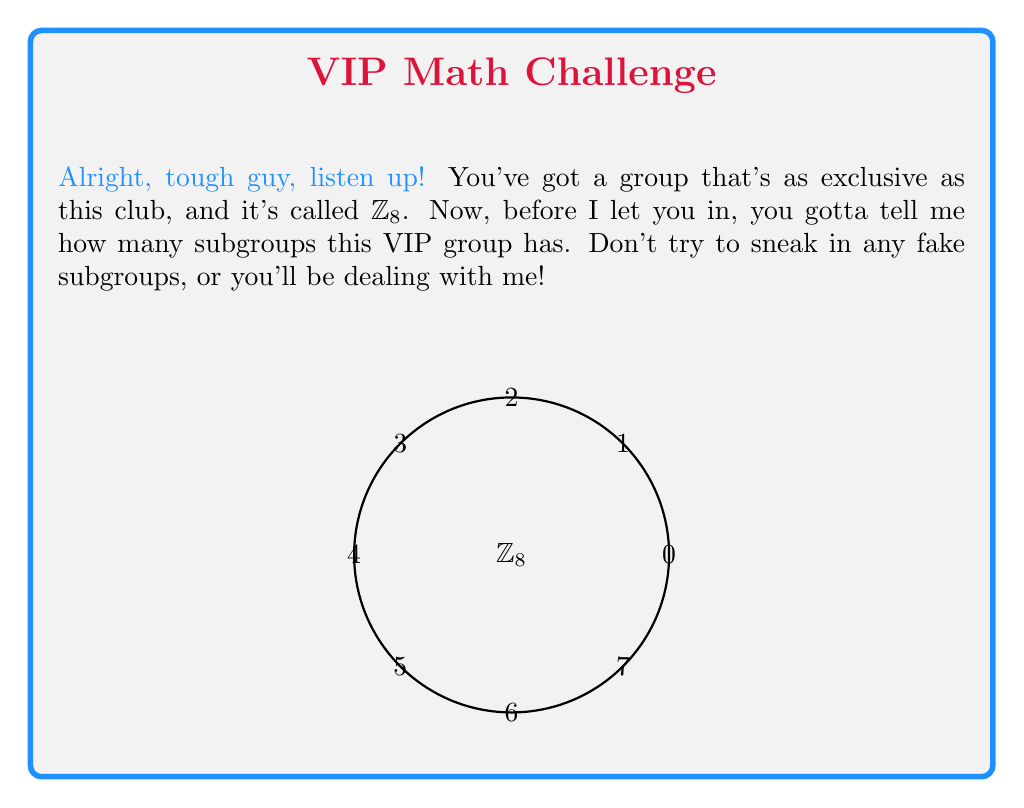Teach me how to tackle this problem. Alright, let's break this down step-by-step, tough guy:

1) First, recall that the order of any subgroup must divide the order of the group. The order of $\mathbb{Z}_8$ is 8, so possible subgroup orders are 1, 2, 4, and 8.

2) The trivial subgroup $\{0\}$ is always present. That's one subgroup.

3) The whole group $\mathbb{Z}_8$ is also a subgroup of itself. That's two subgroups.

4) For subgroups of order 2:
   - We need an element of order 2. In $\mathbb{Z}_8$, only 4 has order 2.
   - So, we have one subgroup of order 2: $\{0,4\}$. That's three subgroups total.

5) For subgroups of order 4:
   - We need an element of order 4. In $\mathbb{Z}_8$, 2 and 6 have order 4.
   - The subgroup generated by 2 is $\{0,2,4,6\}$
   - The subgroup generated by 6 is also $\{0,2,4,6\}$
   - So, we have only one subgroup of order 4. That's four subgroups total.

6) Therefore, $\mathbb{Z}_8$ has exactly 4 subgroups:
   $\{0\}$, $\{0,4\}$, $\{0,2,4,6\}$, and $\mathbb{Z}_8$ itself.

Now, don't make me repeat myself!
Answer: 4 